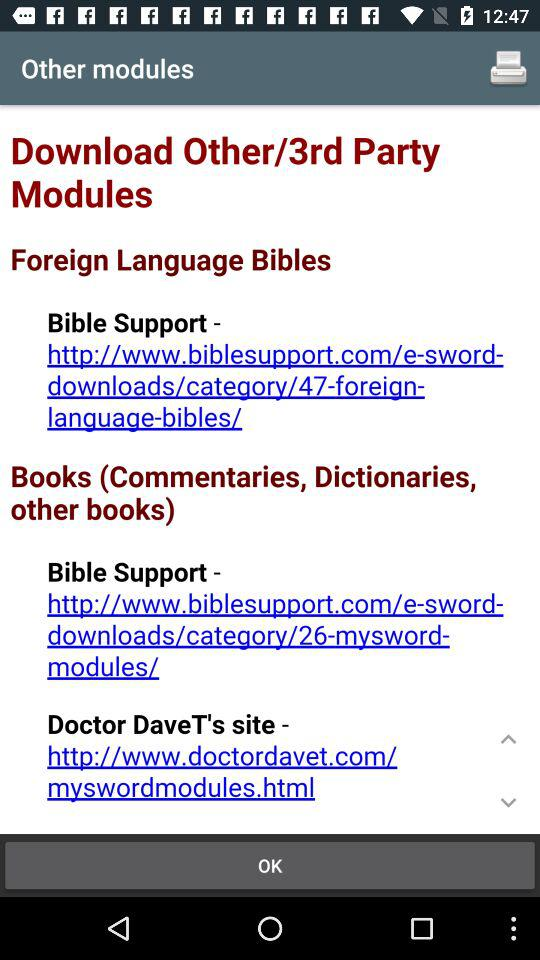What is the URL address of the Bible Support in "Foreign Language Bibles"? The URL address is http://www.biblesupport.com/e-sword-downloads/category/47-foreign-language-bibles/. 